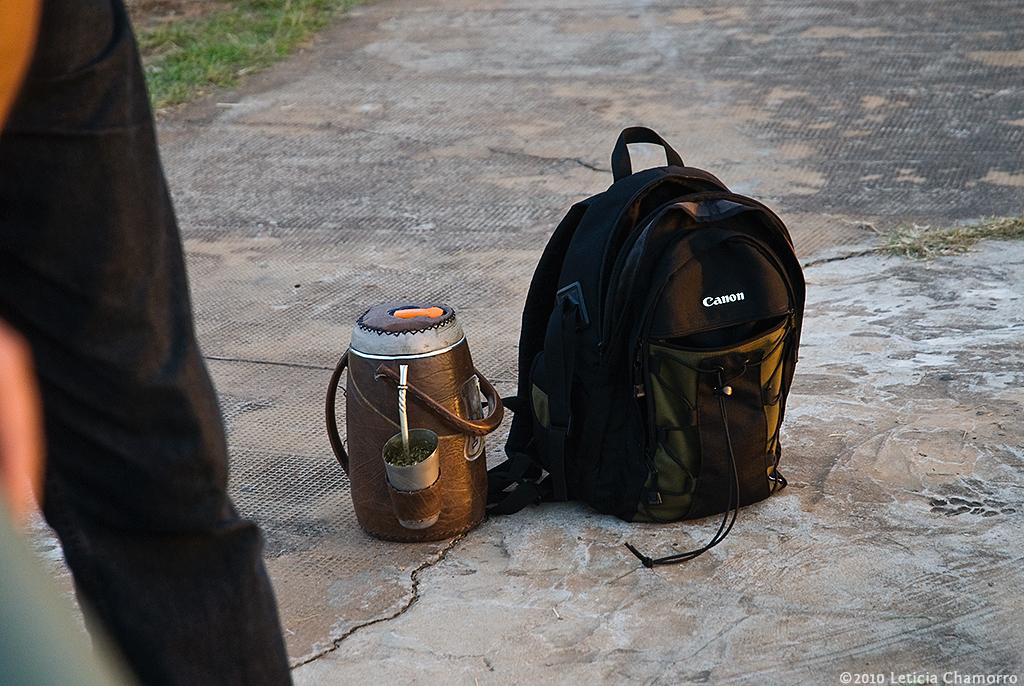Provide a one-sentence caption for the provided image. A container for drinks and a backpack with the logo CANON sit on the cement. 